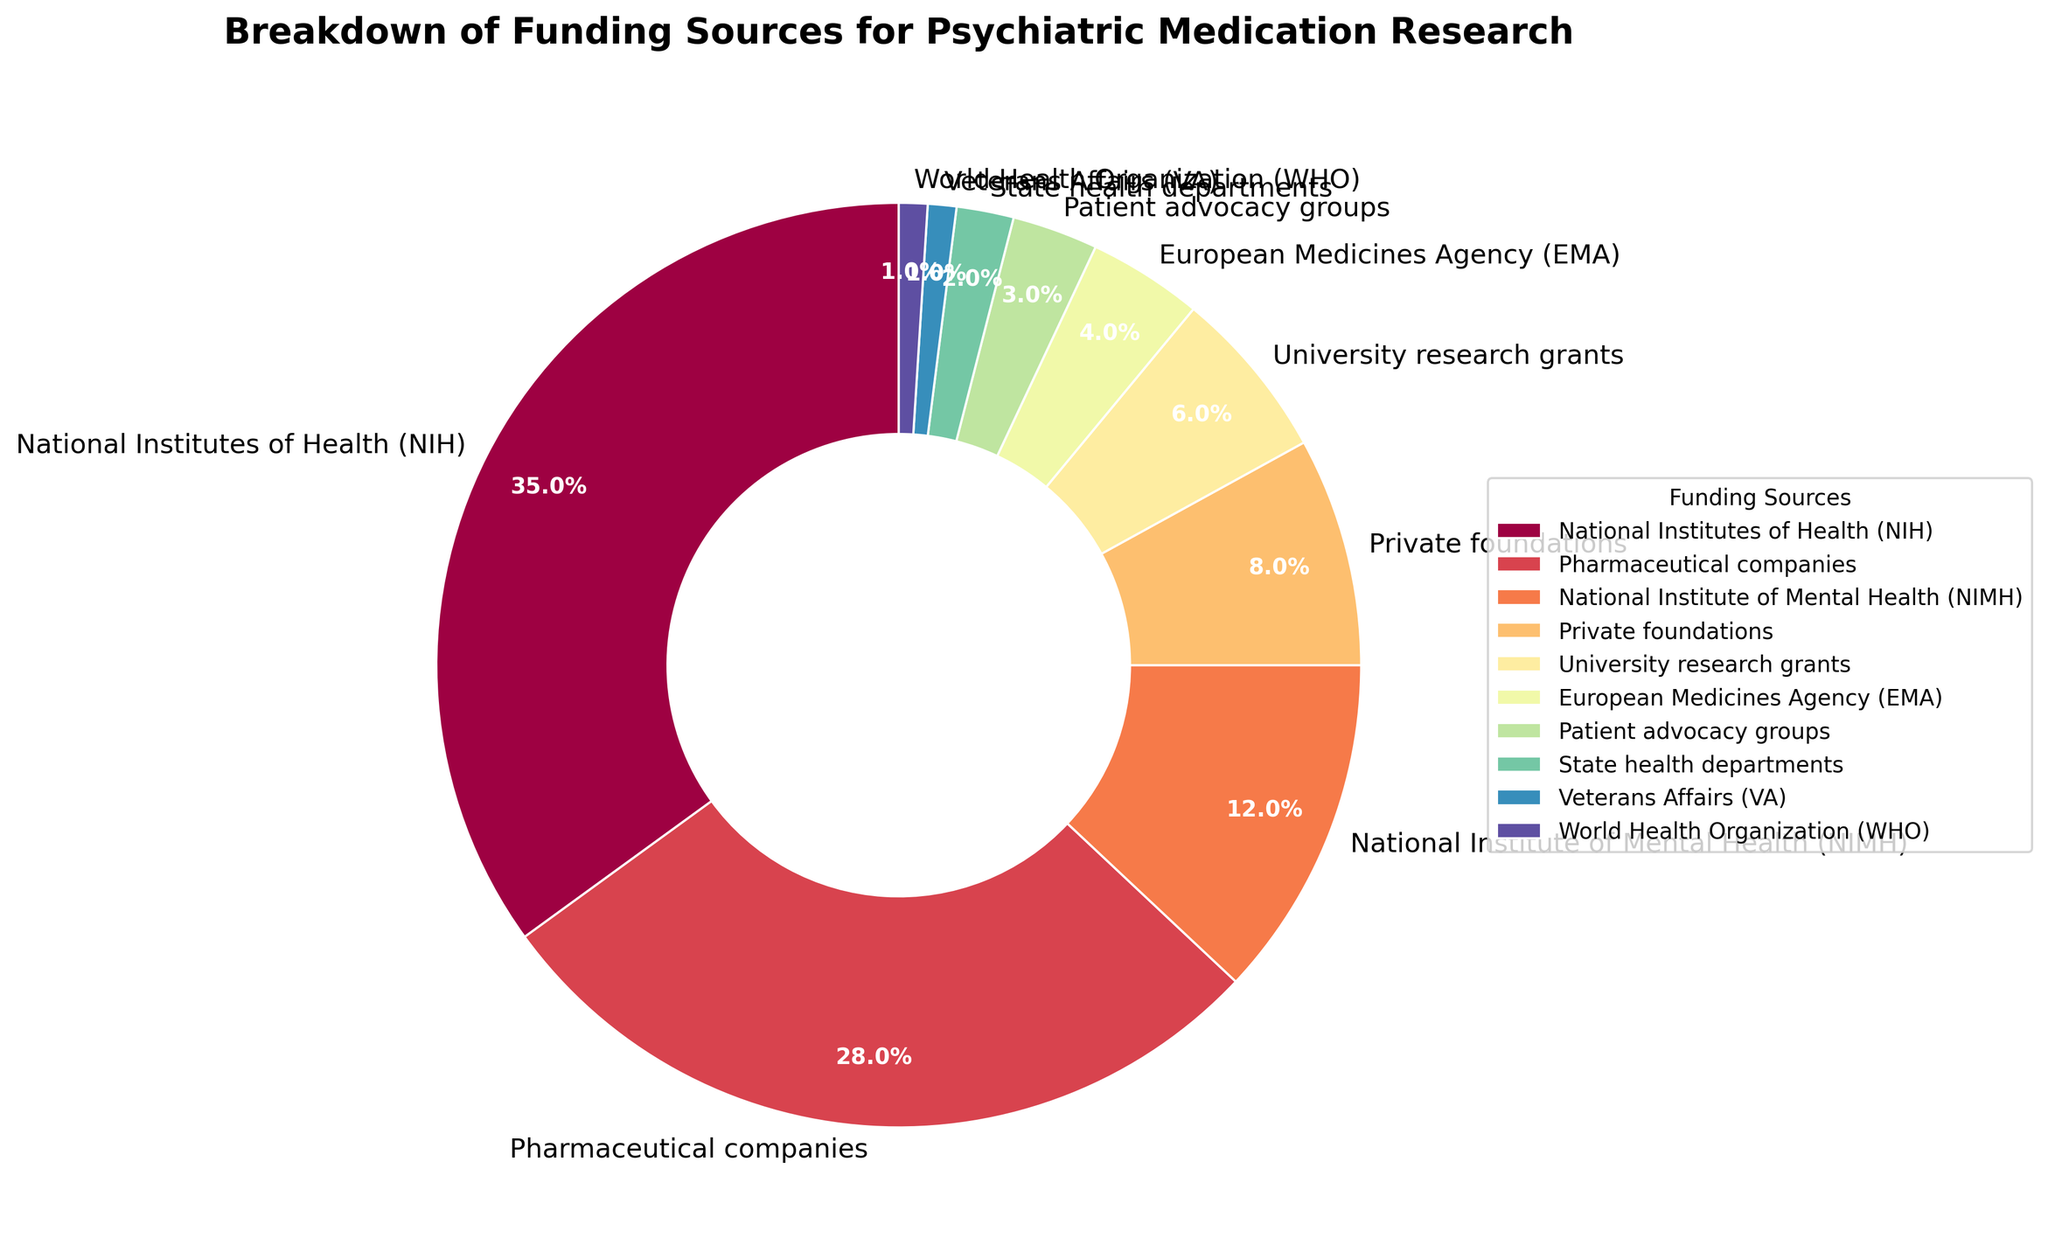What’s the largest funding source for psychiatric medication research? To identify the largest funding source, observe which section of the pie chart covers the largest area. The National Institutes of Health (NIH) covers 35% of the pie chart, making it the largest funding source.
Answer: National Institutes of Health (NIH) How much more funding does NIH provide compared to pharmaceutical companies? The NIH provides 35% of the funding, while pharmaceutical companies provide 28%. Subtracting the pharmaceutical companies' percentage from the NIH's percentage gives 35% - 28% = 7%.
Answer: 7% Which funding sources together provide more than half of the total funding? Identify the sources from the pie chart and sum their percentages until it exceeds 50%. NIH and pharmaceutical companies together provide 35% + 28% = 63%, which is more than half.
Answer: NIH and pharmaceutical companies How does the funding from private foundations compare to that from state health departments? Examine the pie chart's sections for private foundations and state health departments. Private foundations provide 8%, while state health departments contribute 2%. Private foundations provide significantly more funding.
Answer: Private foundations provide 6% more What is the combined percentage of funding from the NIMH and the EMA? Add the percentages provided by the National Institute of Mental Health (NIMH) and the European Medicines Agency (EMA). From the pie chart, NIMH provides 12% and EMA provides 4%, so the total is 12% + 4% = 16%.
Answer: 16% Which funding source contributes equally to the World Health Organization (WHO) in percentage? Compare all sections of the pie chart. The World Health Organization (WHO) provides 1% of the funding, and the Veterans Affairs (VA) also contributes 1%.
Answer: Veterans Affairs (VA) How does the funding from university research grants visually differ from that of patient advocacy groups? Observe the size and label of the sections in the pie chart. University research grants cover 6%, which is slightly larger than the segment for patient advocacy groups, which covers 3%.
Answer: University research grants are larger If you wanted to find all contributors with less than 5% funding, which sources would you look at? Identify pie chart sections with labels less than 5%. EMA, patient advocacy groups, state health departments, VA, and WHO all contribute less than 5%.
Answer: EMA, patient advocacy groups, state health departments, VA, WHO How much less funding does the Veterans Affairs (VA) receive compared to university research grants? University research grants receive 6% and the VA receives 1%. Subtract 1% from 6% to find the difference, which is 6% - 1% = 5%.
Answer: 5% Which sections of the pie chart use the two most similar colors visually? Examine the colormap used in the pie chart visually and identify sections with very similar colors. EMA and patient advocacy groups have very close shades, making them the two most similar.
Answer: EMA and patient advocacy groups 